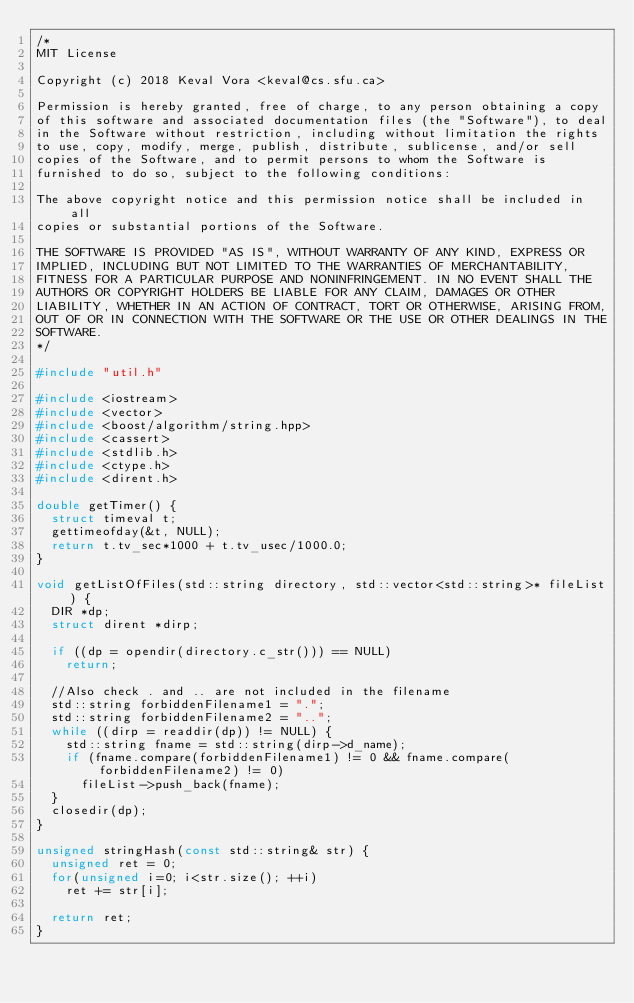Convert code to text. <code><loc_0><loc_0><loc_500><loc_500><_C++_>/*
MIT License

Copyright (c) 2018 Keval Vora <keval@cs.sfu.ca>

Permission is hereby granted, free of charge, to any person obtaining a copy
of this software and associated documentation files (the "Software"), to deal
in the Software without restriction, including without limitation the rights
to use, copy, modify, merge, publish, distribute, sublicense, and/or sell
copies of the Software, and to permit persons to whom the Software is
furnished to do so, subject to the following conditions:

The above copyright notice and this permission notice shall be included in all
copies or substantial portions of the Software.

THE SOFTWARE IS PROVIDED "AS IS", WITHOUT WARRANTY OF ANY KIND, EXPRESS OR
IMPLIED, INCLUDING BUT NOT LIMITED TO THE WARRANTIES OF MERCHANTABILITY,
FITNESS FOR A PARTICULAR PURPOSE AND NONINFRINGEMENT. IN NO EVENT SHALL THE
AUTHORS OR COPYRIGHT HOLDERS BE LIABLE FOR ANY CLAIM, DAMAGES OR OTHER
LIABILITY, WHETHER IN AN ACTION OF CONTRACT, TORT OR OTHERWISE, ARISING FROM,
OUT OF OR IN CONNECTION WITH THE SOFTWARE OR THE USE OR OTHER DEALINGS IN THE
SOFTWARE.
*/

#include "util.h"

#include <iostream>
#include <vector>
#include <boost/algorithm/string.hpp>
#include <cassert>
#include <stdlib.h>
#include <ctype.h>
#include <dirent.h>

double getTimer() {
  struct timeval t;
  gettimeofday(&t, NULL);
  return t.tv_sec*1000 + t.tv_usec/1000.0;
}

void getListOfFiles(std::string directory, std::vector<std::string>* fileList) {
  DIR *dp;
  struct dirent *dirp;

  if ((dp = opendir(directory.c_str())) == NULL)
    return;

  //Also check . and .. are not included in the filename
  std::string forbiddenFilename1 = ".";
  std::string forbiddenFilename2 = "..";
  while ((dirp = readdir(dp)) != NULL) {
    std::string fname = std::string(dirp->d_name);
    if (fname.compare(forbiddenFilename1) != 0 && fname.compare(forbiddenFilename2) != 0)
      fileList->push_back(fname);
  }
  closedir(dp);
}

unsigned stringHash(const std::string& str) {
  unsigned ret = 0;
  for(unsigned i=0; i<str.size(); ++i)
    ret += str[i];

  return ret;
}
</code> 